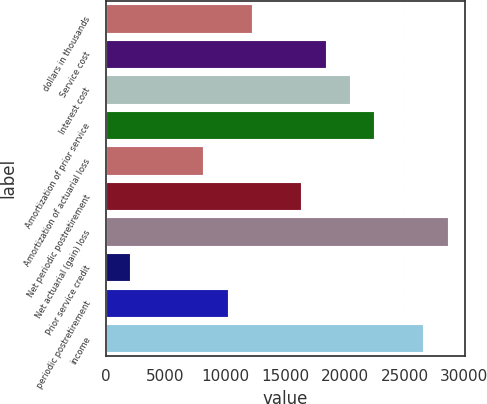Convert chart. <chart><loc_0><loc_0><loc_500><loc_500><bar_chart><fcel>dollars in thousands<fcel>Service cost<fcel>Interest cost<fcel>Amortization of prior service<fcel>Amortization of actuarial loss<fcel>Net periodic postretirement<fcel>Net actuarial (gain) loss<fcel>Prior service credit<fcel>periodic postretirement<fcel>income<nl><fcel>12267.7<fcel>18399.9<fcel>20444<fcel>22488.1<fcel>8179.58<fcel>16355.9<fcel>28620.3<fcel>2047.37<fcel>10223.6<fcel>26576.2<nl></chart> 